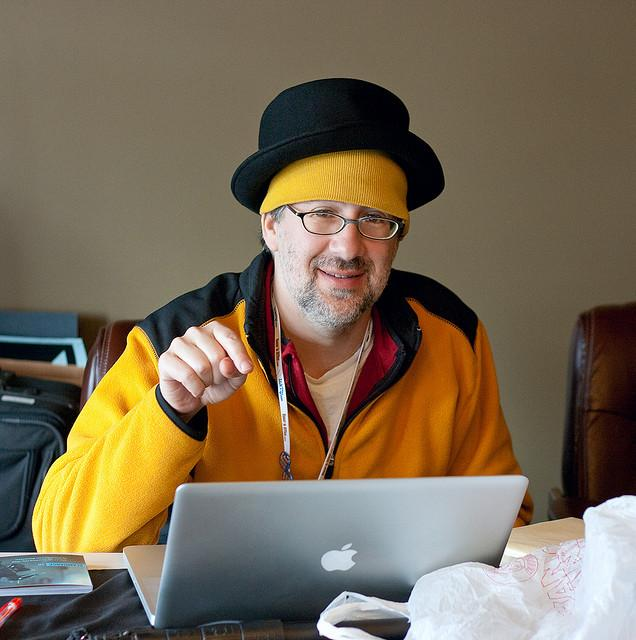What is the man's hat called? Please explain your reasoning. bowler hat. The hat is made out of felt. 